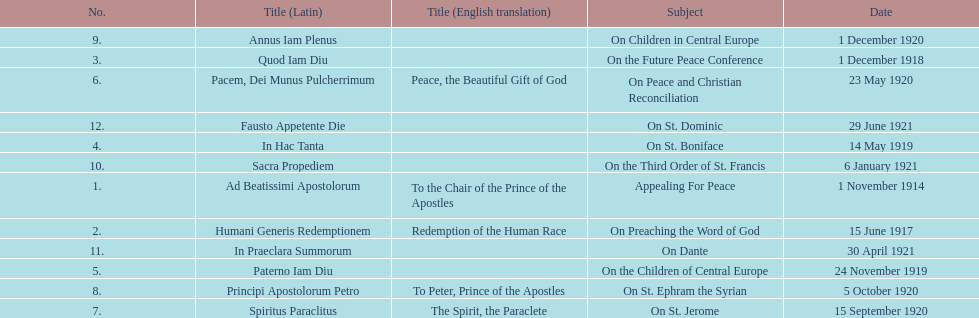What is the total number of encyclicals to take place in december? 2. 